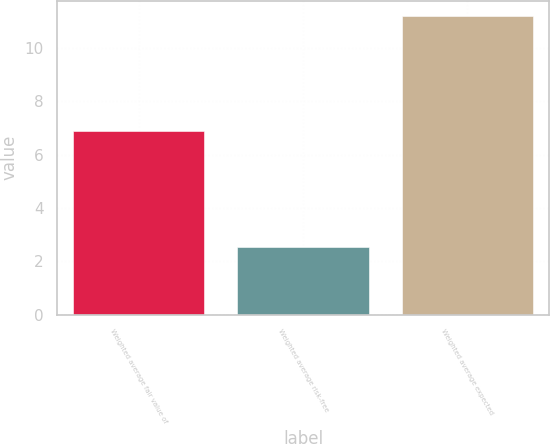Convert chart to OTSL. <chart><loc_0><loc_0><loc_500><loc_500><bar_chart><fcel>Weighted average fair value of<fcel>Weighted average risk-free<fcel>Weighted average expected<nl><fcel>6.87<fcel>2.54<fcel>11.2<nl></chart> 